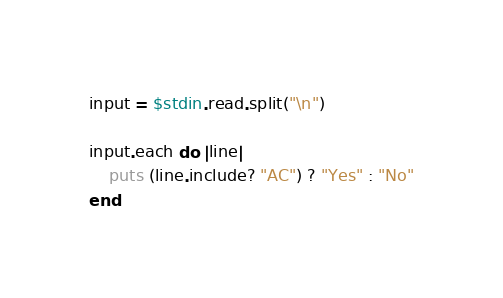<code> <loc_0><loc_0><loc_500><loc_500><_Ruby_>input = $stdin.read.split("\n")

input.each do |line|
    puts (line.include? "AC") ? "Yes" : "No"
end

</code> 